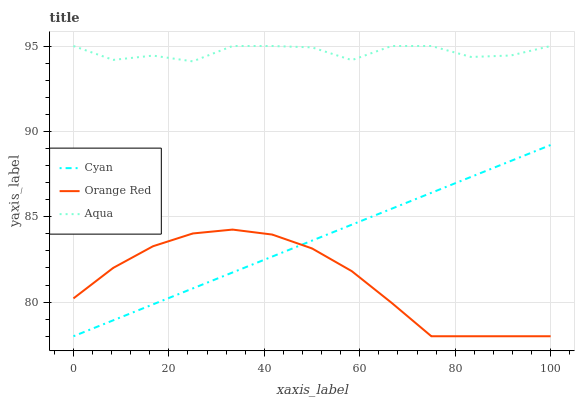Does Orange Red have the minimum area under the curve?
Answer yes or no. Yes. Does Aqua have the maximum area under the curve?
Answer yes or no. Yes. Does Aqua have the minimum area under the curve?
Answer yes or no. No. Does Orange Red have the maximum area under the curve?
Answer yes or no. No. Is Cyan the smoothest?
Answer yes or no. Yes. Is Aqua the roughest?
Answer yes or no. Yes. Is Orange Red the smoothest?
Answer yes or no. No. Is Orange Red the roughest?
Answer yes or no. No. Does Cyan have the lowest value?
Answer yes or no. Yes. Does Aqua have the lowest value?
Answer yes or no. No. Does Aqua have the highest value?
Answer yes or no. Yes. Does Orange Red have the highest value?
Answer yes or no. No. Is Orange Red less than Aqua?
Answer yes or no. Yes. Is Aqua greater than Cyan?
Answer yes or no. Yes. Does Cyan intersect Orange Red?
Answer yes or no. Yes. Is Cyan less than Orange Red?
Answer yes or no. No. Is Cyan greater than Orange Red?
Answer yes or no. No. Does Orange Red intersect Aqua?
Answer yes or no. No. 